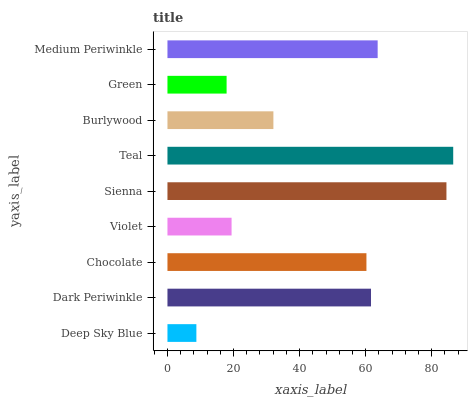Is Deep Sky Blue the minimum?
Answer yes or no. Yes. Is Teal the maximum?
Answer yes or no. Yes. Is Dark Periwinkle the minimum?
Answer yes or no. No. Is Dark Periwinkle the maximum?
Answer yes or no. No. Is Dark Periwinkle greater than Deep Sky Blue?
Answer yes or no. Yes. Is Deep Sky Blue less than Dark Periwinkle?
Answer yes or no. Yes. Is Deep Sky Blue greater than Dark Periwinkle?
Answer yes or no. No. Is Dark Periwinkle less than Deep Sky Blue?
Answer yes or no. No. Is Chocolate the high median?
Answer yes or no. Yes. Is Chocolate the low median?
Answer yes or no. Yes. Is Green the high median?
Answer yes or no. No. Is Violet the low median?
Answer yes or no. No. 